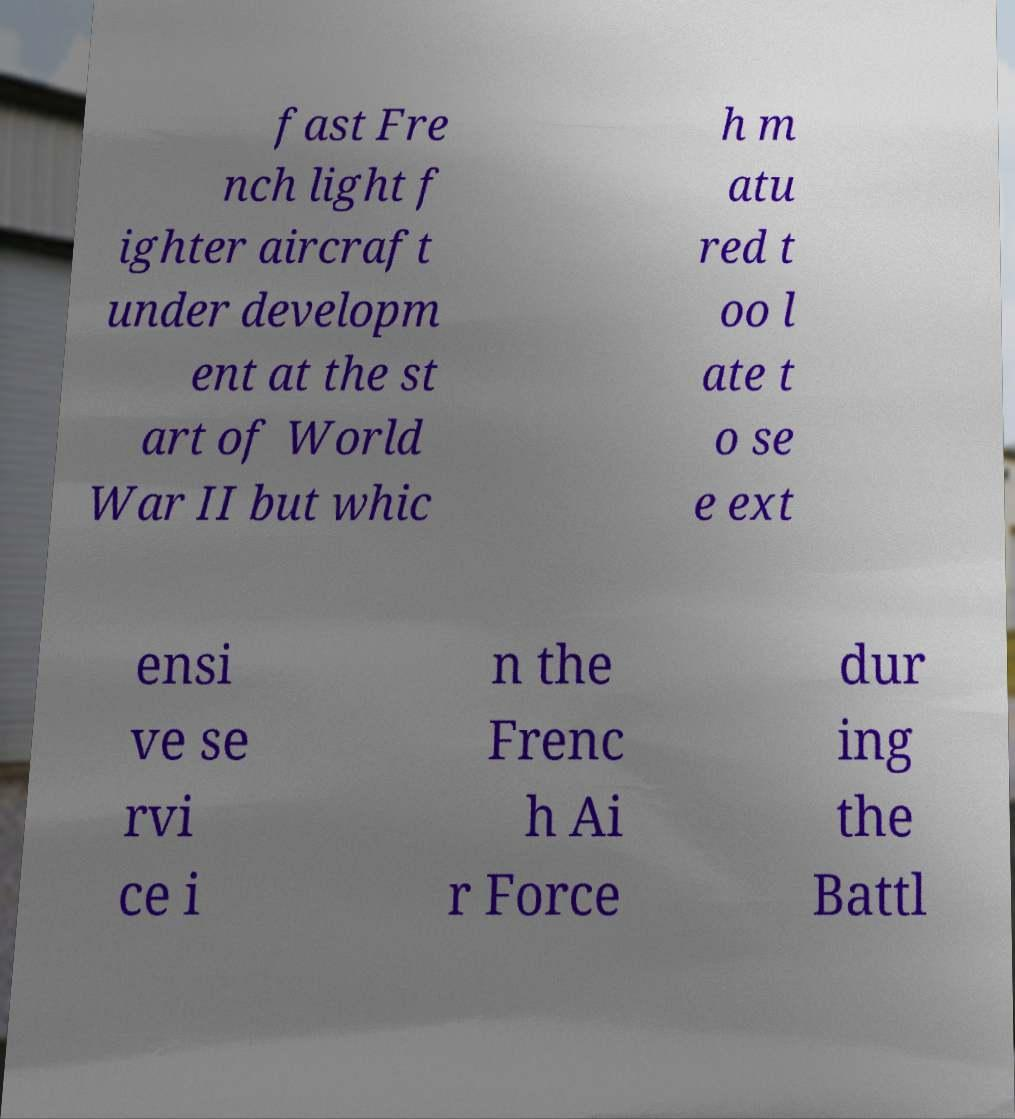Please identify and transcribe the text found in this image. fast Fre nch light f ighter aircraft under developm ent at the st art of World War II but whic h m atu red t oo l ate t o se e ext ensi ve se rvi ce i n the Frenc h Ai r Force dur ing the Battl 